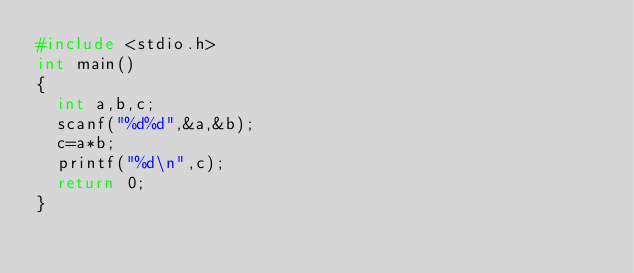Convert code to text. <code><loc_0><loc_0><loc_500><loc_500><_C_>#include <stdio.h>
int main()
{
  int a,b,c;
  scanf("%d%d",&a,&b);
  c=a*b;
  printf("%d\n",c);
  return 0;
}</code> 